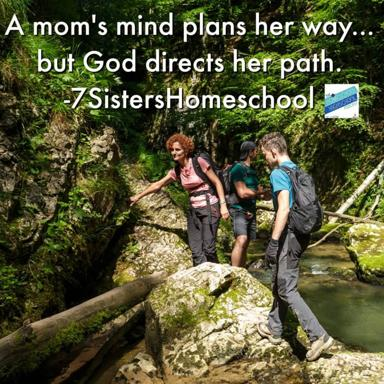What is the message in the text on the image? The text on the image states, 'A mom's mind plans her way, but God directs her path,' which is attributed to 7SistersHomeschool. This suggests a philosophical reflection on the interplay between human intentions and divine guidance, illustrating how personal plans are ultimately harmonized with divine will, enhancing the serene, natural backdrop depicted in the image where a group is carefully navigating a forest stream. 